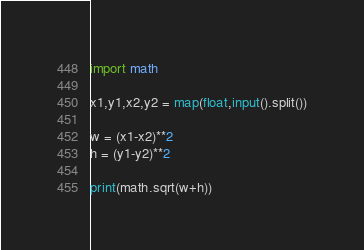<code> <loc_0><loc_0><loc_500><loc_500><_Python_>import math

x1,y1,x2,y2 = map(float,input().split())

w = (x1-x2)**2
h = (y1-y2)**2

print(math.sqrt(w+h))
</code> 